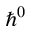Convert formula to latex. <formula><loc_0><loc_0><loc_500><loc_500>\hbar { ^ } { 0 }</formula> 